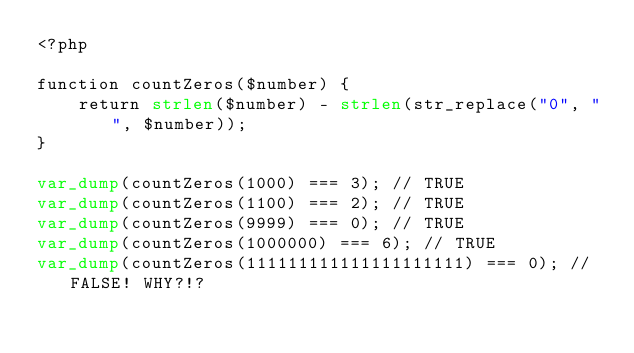<code> <loc_0><loc_0><loc_500><loc_500><_PHP_><?php

function countZeros($number) {
	return strlen($number) - strlen(str_replace("0", "", $number));
}

var_dump(countZeros(1000) === 3); // TRUE
var_dump(countZeros(1100) === 2); // TRUE
var_dump(countZeros(9999) === 0); // TRUE
var_dump(countZeros(1000000) === 6); // TRUE
var_dump(countZeros(111111111111111111111) === 0); // FALSE! WHY?!?</code> 